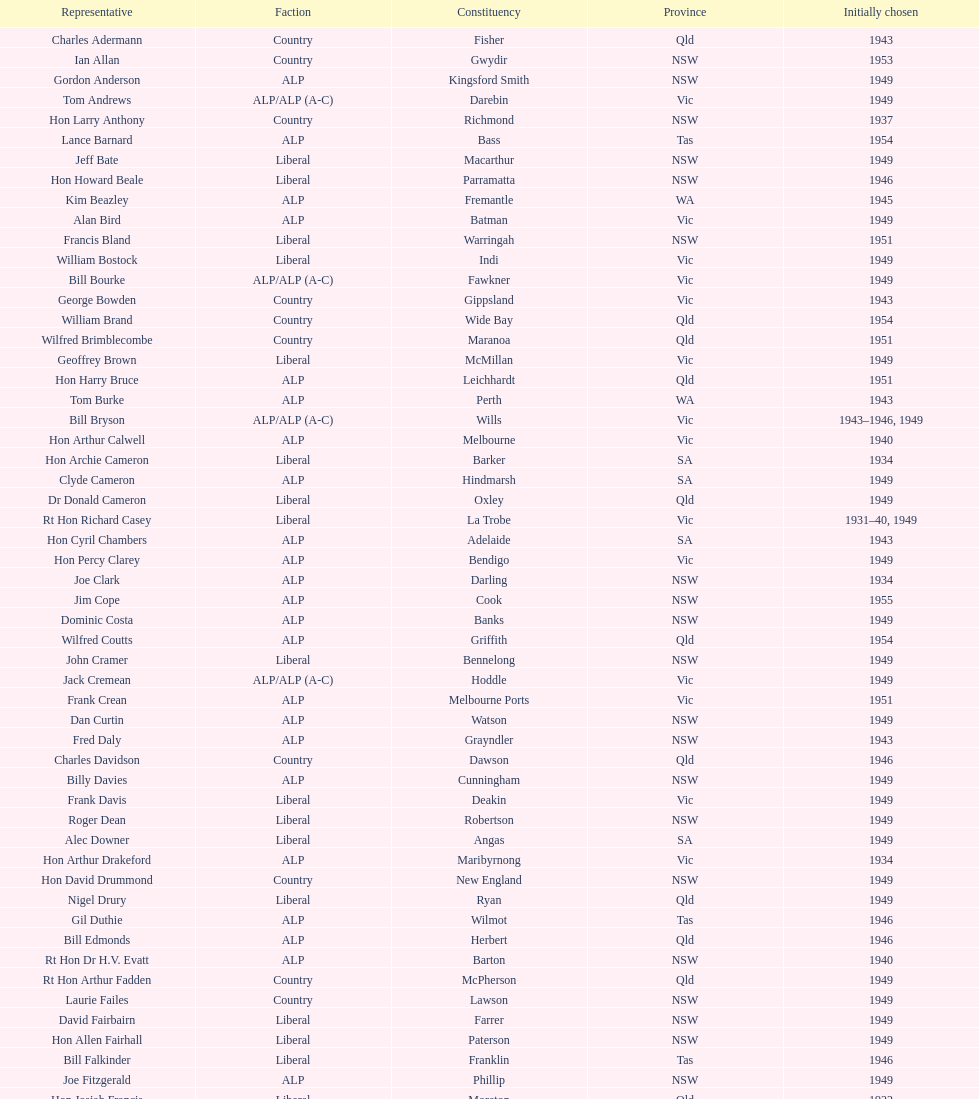Which party was elected the least? Country. 